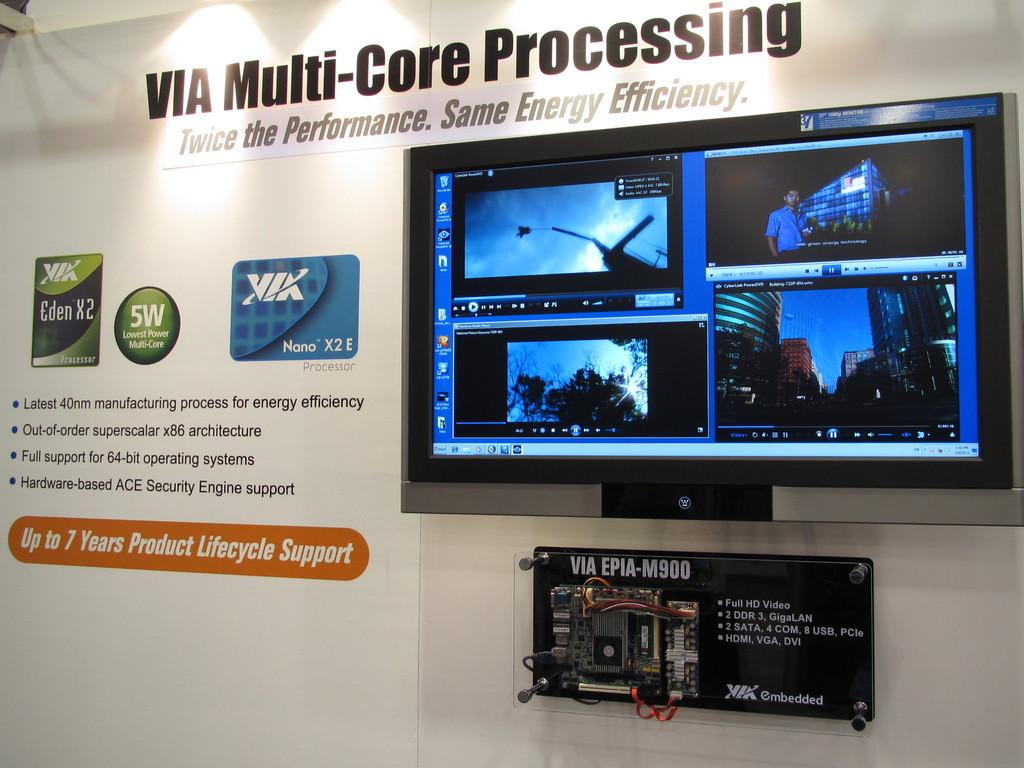Provide a one-sentence caption for the provided image. A poster with a TV screen next to ads for KiK and a 5W sign. 